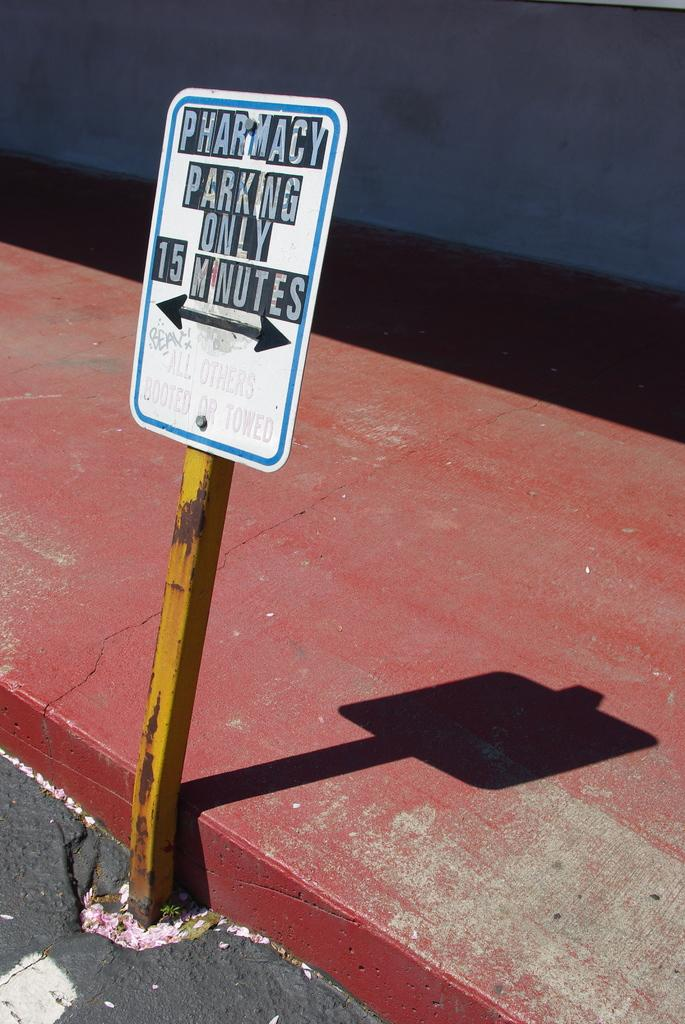<image>
Create a compact narrative representing the image presented. A sign reads Pharmacy Parking Only 15 MInutes. 